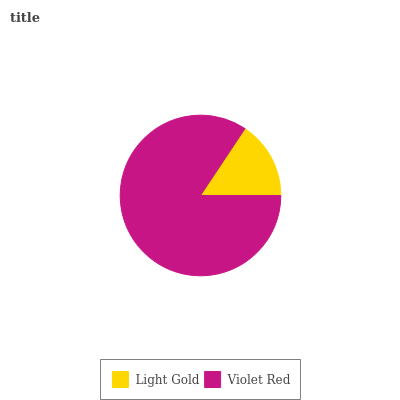Is Light Gold the minimum?
Answer yes or no. Yes. Is Violet Red the maximum?
Answer yes or no. Yes. Is Violet Red the minimum?
Answer yes or no. No. Is Violet Red greater than Light Gold?
Answer yes or no. Yes. Is Light Gold less than Violet Red?
Answer yes or no. Yes. Is Light Gold greater than Violet Red?
Answer yes or no. No. Is Violet Red less than Light Gold?
Answer yes or no. No. Is Violet Red the high median?
Answer yes or no. Yes. Is Light Gold the low median?
Answer yes or no. Yes. Is Light Gold the high median?
Answer yes or no. No. Is Violet Red the low median?
Answer yes or no. No. 